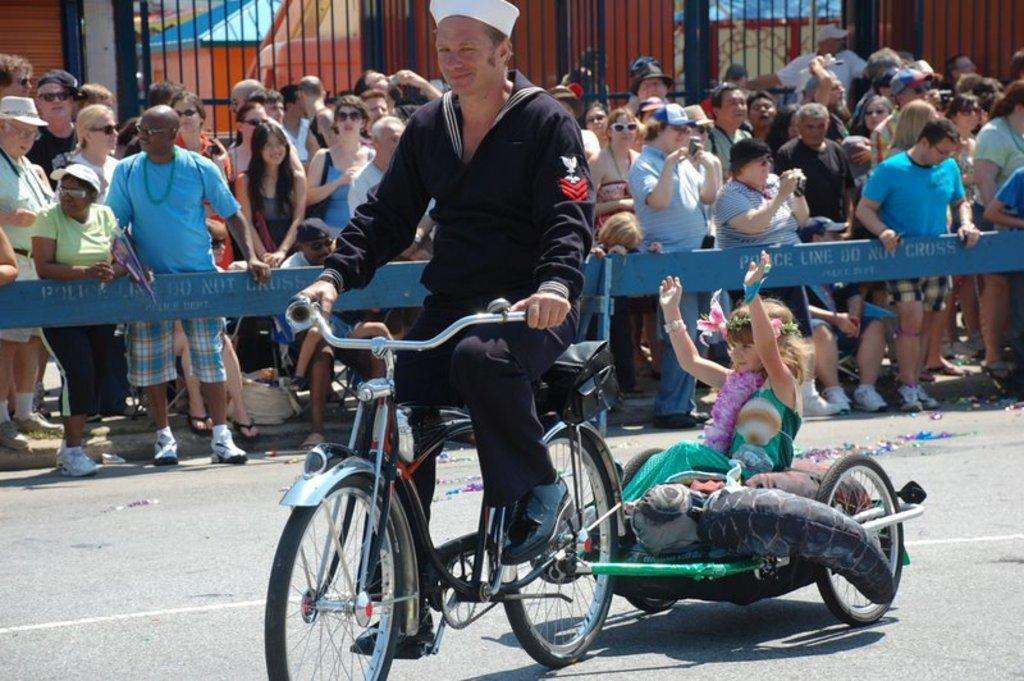What is happening in the image involving a man and a cycle? A man is cycling his cycle in the image. What is the position of the girl in the image? A girl is sitting in the image. Can you describe the activities of the people in the image? The man is cycling, and the girl is sitting. What type of nose can be seen on the horse in the image? There is no horse present in the image, so it is not possible to answer that question. 